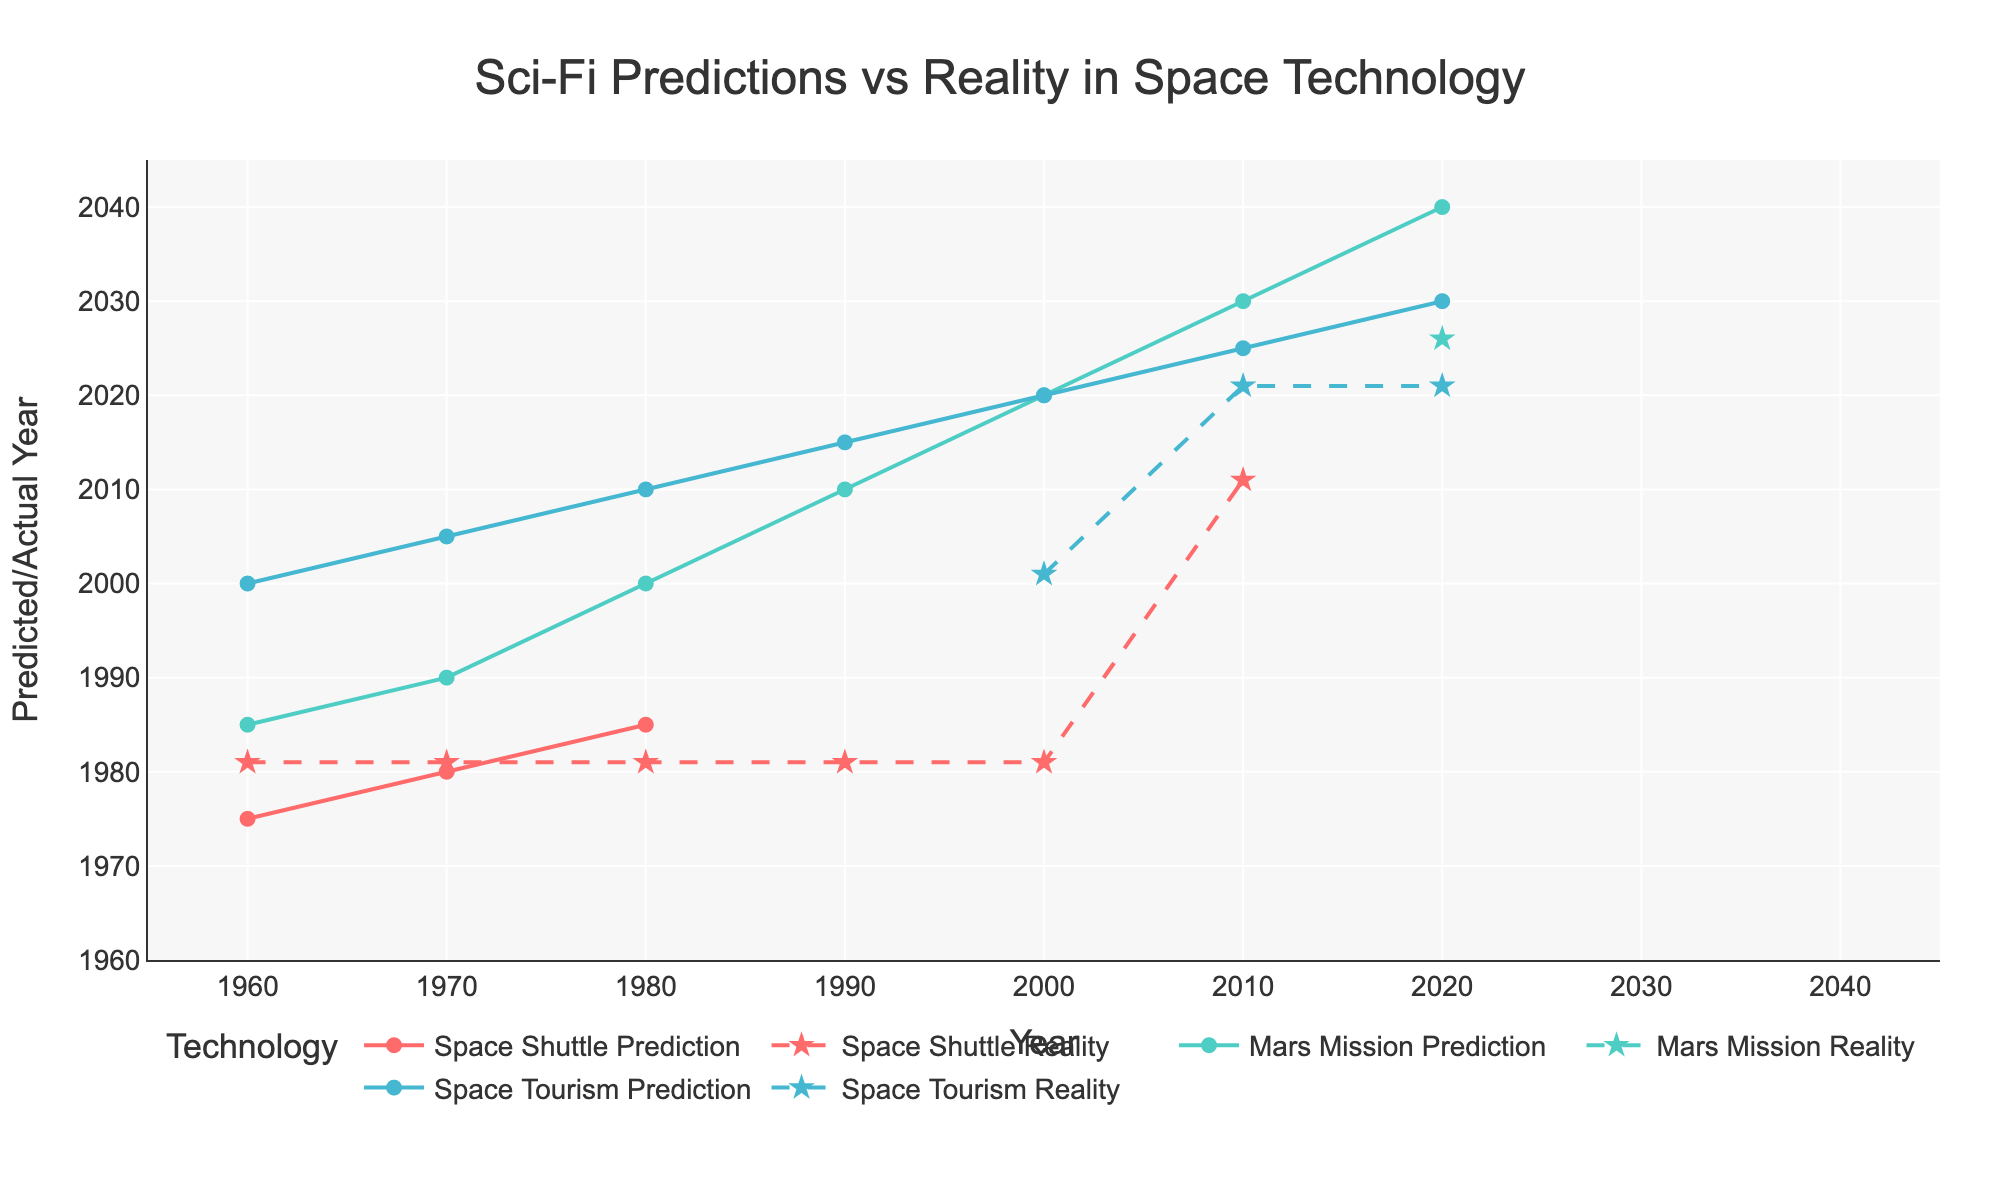How many years later than predicted was the reality for the space shuttle launch in the 1960s? The prediction for the space shuttle launch in the 1960s was 1975, and the actual launch year was 1981. Subtract the predicted year from the actual year: 1981 - 1975 = 6 years.
Answer: 6 years Which category has the largest gap between predictions and reality in the most recent data? The most recent data from 2020 shows gaps between predictions and reality for the Mars Mission and Space Tourism. The Mars Mission is predicted for 2030 and reality for 2026, a 4-year difference. Space Tourism is predicted for 2030, but the reality is 2021, a 9-year difference. Thus, Space Tourism has the largest gap with 9 years.
Answer: Space Tourism In which decade did the predictions for Mars missions begin to closely align with their actual realization? Looking at the Mars mission data, the prediction for 2020 was closest to the actual realization in 2026, a gap of 6 years. The other decades had larger gaps.
Answer: 2020s How did the prediction of space tourism in the 1970s compare to its actual realization? In the 1970s, the prediction was for space tourism to be realized by 2005; however, the actual realization happened in 2021. The difference between predicted and actual years is 2021 - 2005 = 16 years.
Answer: 16 years later In the 1980s, which category's prediction was the most accurate compared to reality? In the 1980s, the predictions were: Space Shuttle (1985, actual 1981), Mars Mission (2000, actual N/A), and Space Tourism (2010, actual N/A). The Space Shuttle prediction was 4 years earlier than its actual realization, whereas the others had no realizations by those dates. Thus, Space Shuttle prediction was the most accurate.
Answer: Space Shuttle What is the total gap between all predictions and realizations of the Space Shuttle from the 1960s to 2000s? The Space Shuttle had predictions in the 1960s (1975), 1970s (1980), and 1980s (1985); its realizations were all in 1981. The gaps are: 1981-1975 = 6, 1981-1980 = 1, 1981-1985 = 4. Total: 6 + 1 + 4 = 11 years.
Answer: 11 years Which prediction was the furthest off from reality for Mars missions between 1960s and 2010? The furthest off prediction for Mars missions was in the 1980s, which predicted 2000, but the actual realization is still unknown (N/A), marking it as the least accurate prediction.
Answer: 1980s prediction for 2000 